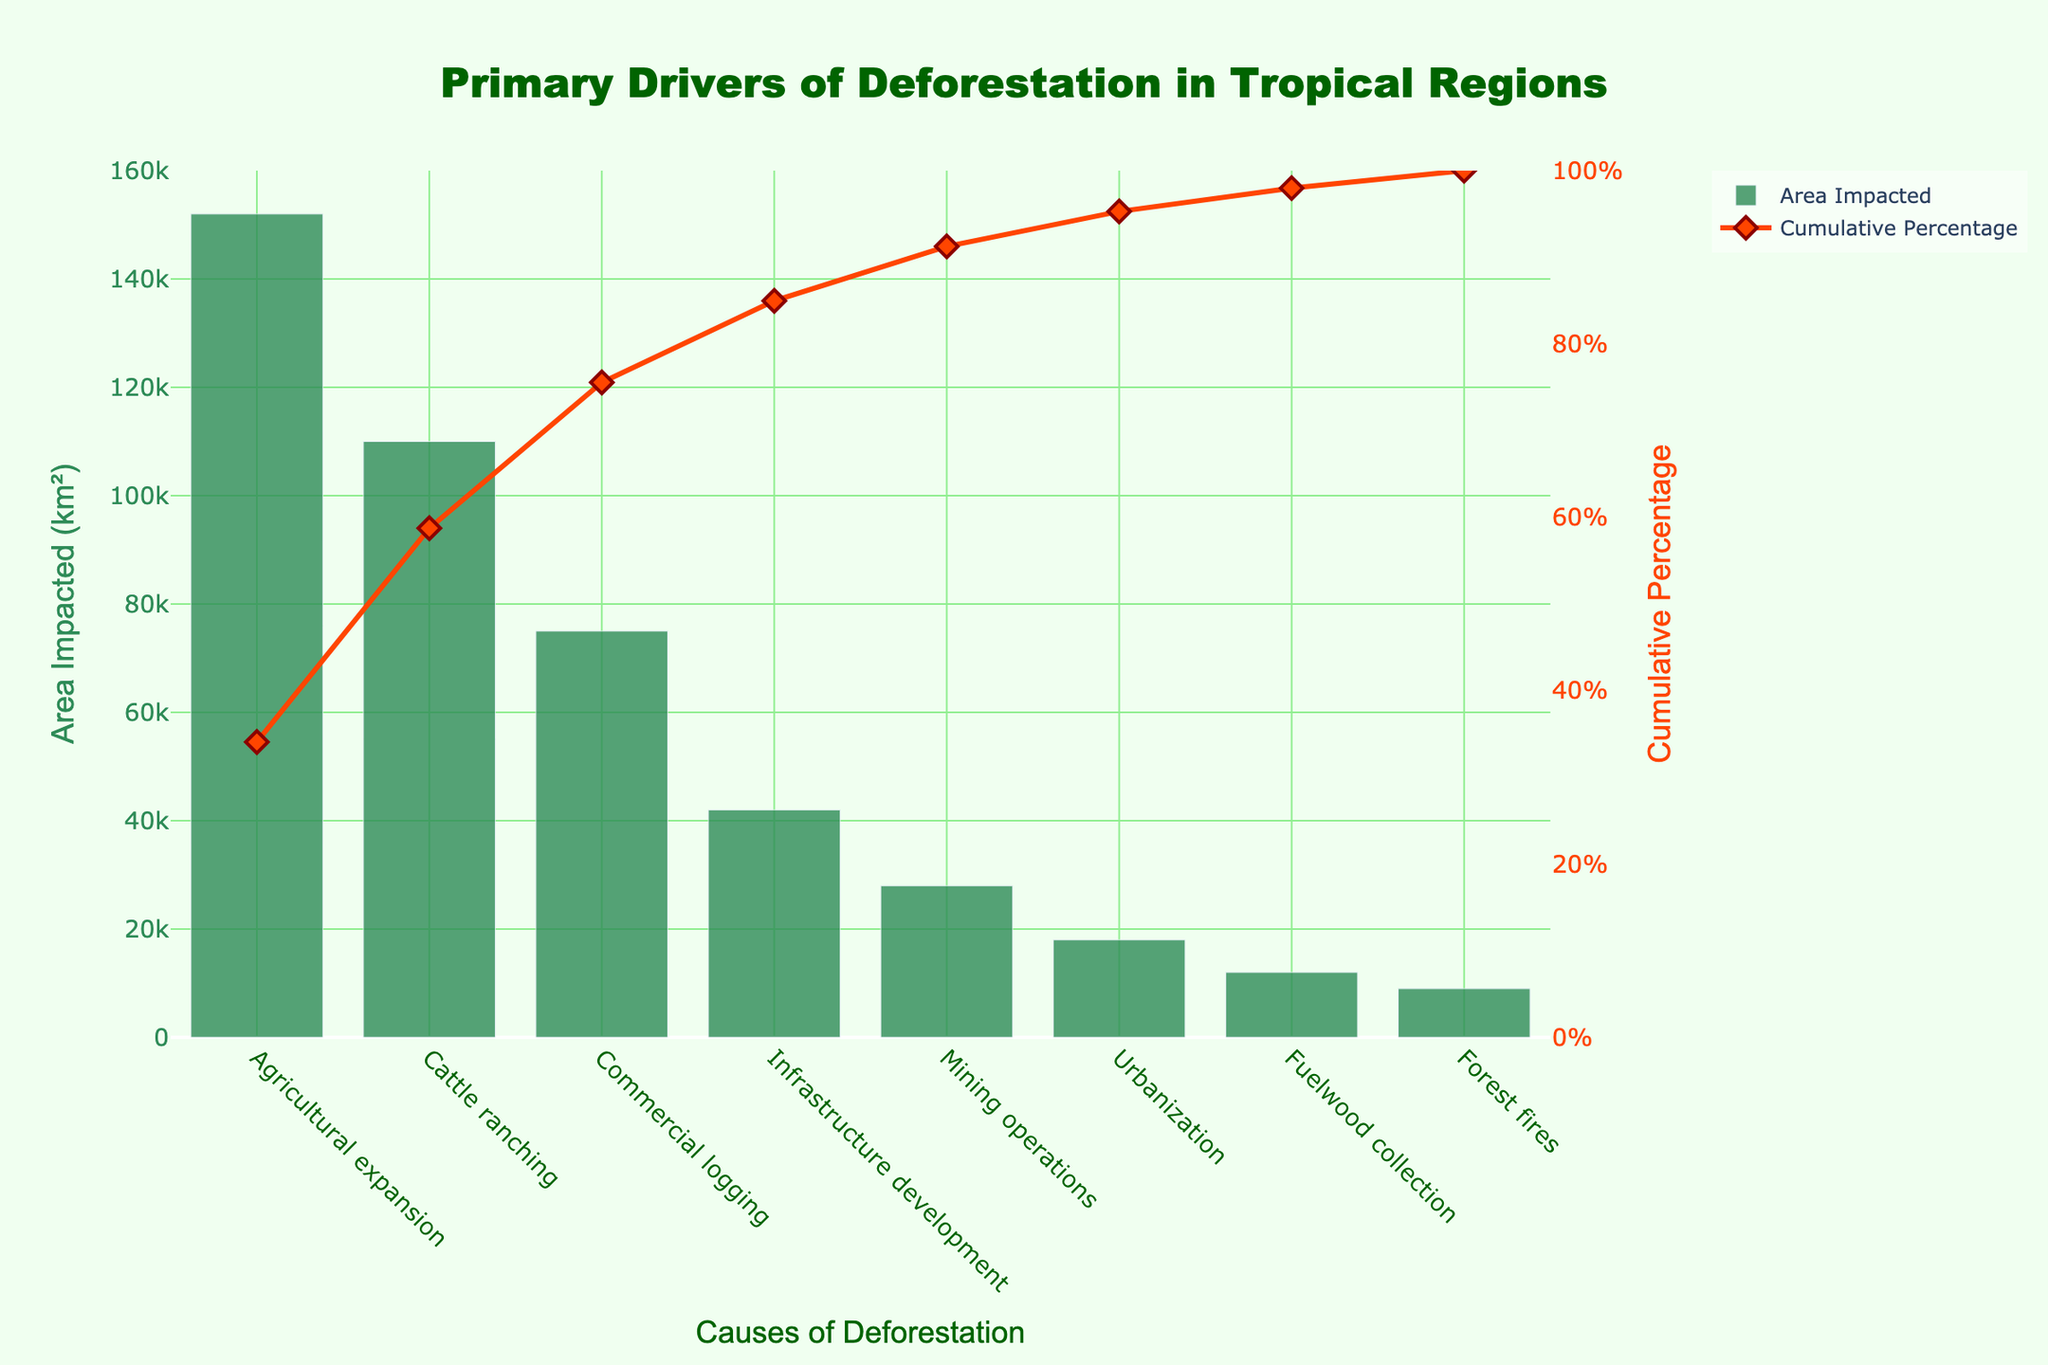what is the title of the chart? The title is usually displayed prominently at the top of the chart. In this case, it is "Primary Drivers of Deforestation in Tropical Regions" which indicates the main causes of deforestation in those areas.
Answer: Primary Drivers of Deforestation in Tropical Regions What is the secondary y-axis title? The secondary y-axis title is shown on the right side of the graph, and it indicates the unit of measurement for the line trace. For this chart, it is "Cumulative Percentage".
Answer: Cumulative Percentage Which cause has the highest impact on deforestation? The tallest bar on the chart represents the cause with the highest area impacted. For this chart, it is "Agricultural expansion" with an impacted area of 152,000 km².
Answer: Agricultural expansion Which cause has the lowest area impacted? The shortest bar represents the cause with the lowest area impacted. Fuelwood collection and Forest fires have the shortest bars, but Forest fires has the lowest area impacted at 9,000 km².
Answer: Forest fires What is the cumulative percentage after Commercial logging? To find the cumulative percentage after Commercial logging, we look at the point in the line trace aligned with Commercial logging. The cumulative percentage here is approximately 83%.
Answer: Approximately 83% How does the impact of Commercial logging compare to Cattle ranching? We compare the height of the bars for Commercial logging and Cattle ranching. Cattle ranching has a taller bar at 110,000 km², whereas Commercial logging is 75,000 km². Thus, Cattle ranching has a higher impact.
Answer: Cattle ranching has a higher impact What percentage of deforestation causes are attributed to Agricultural expansion and Cattle ranching combined? First add the impacted area for Agricultural expansion (152,000 km²) and Cattle ranching (110,000 km²) to get 262,000 km². Then divide this by the total impacted area (444,000 km²) and multiply by 100 to get approximately 59%.
Answer: Approximately 59% If we consider the top three causes of deforestation, what is their combined cumulative percentage? The top three causes are Agricultural expansion, Cattle ranching, and Commercial logging. Summing up their individual cumulative percentages (34%, 59%, 83%) yields a combined percentage of 83%, which can be directly read from the cumulative percentage line after the third cause.
Answer: 83% What is the area impacted by Mining operations relative to Urbanization? Compare the height of the bars for Mining operations (28,000 km²) to Urbanization (18,000 km²). Mining operations impact an area that is 10,000 km² larger than Urbanization.
Answer: 10,000 km² larger How many causes contribute to nearly 90% of the affected area? We look at the cumulative percentage line and identify where it first reaches or exceeds 90%. This occurs between Infrastructure development and Mining operations. Thus, the first five causes contribute to nearly 90% of the deforested area.
Answer: Five causes What is the visual appearance of the bars and markers? The bars representing the area impacted are green, slightly transparent with an opacity of 0.8. The line trace for cumulative percentage has red-orange lines with markers shaped like diamonds and an outer red border.
Answer: Green bars, red-orange line, diamond markers 